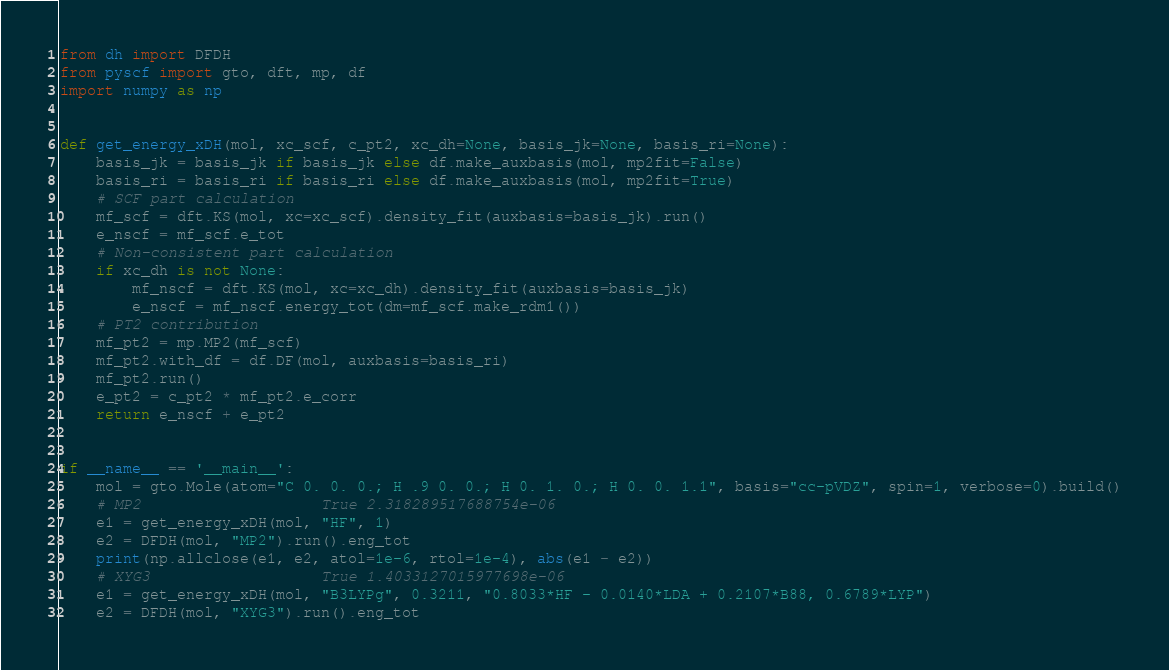Convert code to text. <code><loc_0><loc_0><loc_500><loc_500><_Python_>from dh import DFDH
from pyscf import gto, dft, mp, df
import numpy as np


def get_energy_xDH(mol, xc_scf, c_pt2, xc_dh=None, basis_jk=None, basis_ri=None):
    basis_jk = basis_jk if basis_jk else df.make_auxbasis(mol, mp2fit=False)
    basis_ri = basis_ri if basis_ri else df.make_auxbasis(mol, mp2fit=True)
    # SCF part calculation
    mf_scf = dft.KS(mol, xc=xc_scf).density_fit(auxbasis=basis_jk).run()
    e_nscf = mf_scf.e_tot
    # Non-consistent part calculation
    if xc_dh is not None:
        mf_nscf = dft.KS(mol, xc=xc_dh).density_fit(auxbasis=basis_jk)
        e_nscf = mf_nscf.energy_tot(dm=mf_scf.make_rdm1())
    # PT2 contribution
    mf_pt2 = mp.MP2(mf_scf)
    mf_pt2.with_df = df.DF(mol, auxbasis=basis_ri)
    mf_pt2.run()
    e_pt2 = c_pt2 * mf_pt2.e_corr
    return e_nscf + e_pt2


if __name__ == '__main__':
    mol = gto.Mole(atom="C 0. 0. 0.; H .9 0. 0.; H 0. 1. 0.; H 0. 0. 1.1", basis="cc-pVDZ", spin=1, verbose=0).build()
    # MP2                    True 2.318289517688754e-06
    e1 = get_energy_xDH(mol, "HF", 1)
    e2 = DFDH(mol, "MP2").run().eng_tot
    print(np.allclose(e1, e2, atol=1e-6, rtol=1e-4), abs(e1 - e2))
    # XYG3                   True 1.4033127015977698e-06
    e1 = get_energy_xDH(mol, "B3LYPg", 0.3211, "0.8033*HF - 0.0140*LDA + 0.2107*B88, 0.6789*LYP")
    e2 = DFDH(mol, "XYG3").run().eng_tot</code> 